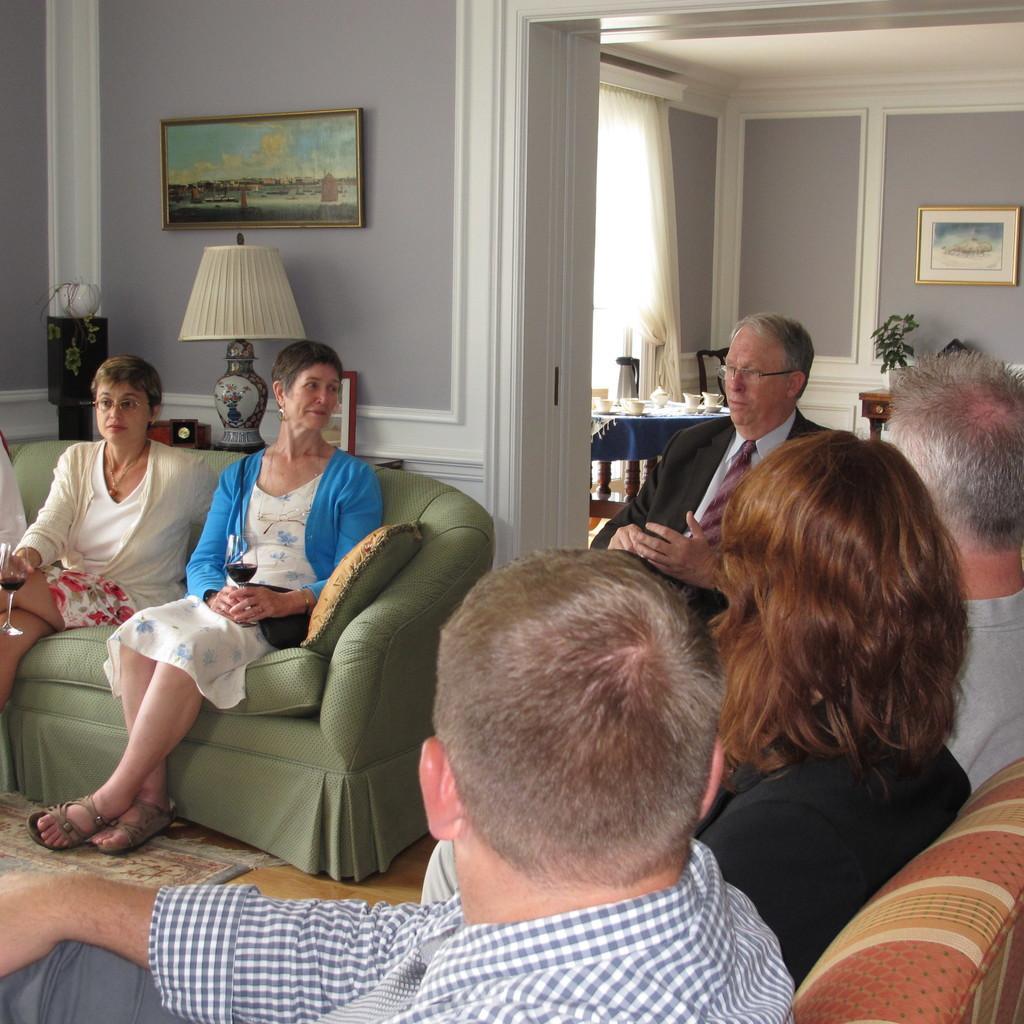Please provide a concise description of this image. This picture describes about group of people, they are seated on the sofas, in the background we can see a light and other things on the table, in the background we can find a table and paintings on the wall. 